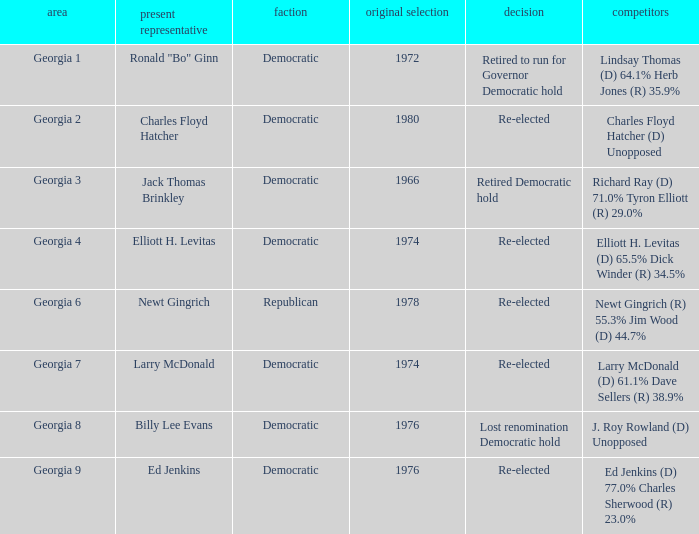Could you parse the entire table? {'header': ['area', 'present representative', 'faction', 'original selection', 'decision', 'competitors'], 'rows': [['Georgia 1', 'Ronald "Bo" Ginn', 'Democratic', '1972', 'Retired to run for Governor Democratic hold', 'Lindsay Thomas (D) 64.1% Herb Jones (R) 35.9%'], ['Georgia 2', 'Charles Floyd Hatcher', 'Democratic', '1980', 'Re-elected', 'Charles Floyd Hatcher (D) Unopposed'], ['Georgia 3', 'Jack Thomas Brinkley', 'Democratic', '1966', 'Retired Democratic hold', 'Richard Ray (D) 71.0% Tyron Elliott (R) 29.0%'], ['Georgia 4', 'Elliott H. Levitas', 'Democratic', '1974', 'Re-elected', 'Elliott H. Levitas (D) 65.5% Dick Winder (R) 34.5%'], ['Georgia 6', 'Newt Gingrich', 'Republican', '1978', 'Re-elected', 'Newt Gingrich (R) 55.3% Jim Wood (D) 44.7%'], ['Georgia 7', 'Larry McDonald', 'Democratic', '1974', 'Re-elected', 'Larry McDonald (D) 61.1% Dave Sellers (R) 38.9%'], ['Georgia 8', 'Billy Lee Evans', 'Democratic', '1976', 'Lost renomination Democratic hold', 'J. Roy Rowland (D) Unopposed'], ['Georgia 9', 'Ed Jenkins', 'Democratic', '1976', 'Re-elected', 'Ed Jenkins (D) 77.0% Charles Sherwood (R) 23.0%']]} Name the party for jack thomas brinkley Democratic. 